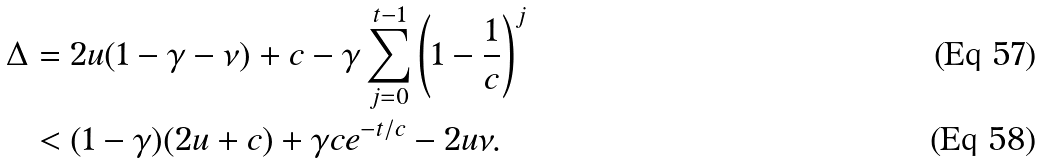Convert formula to latex. <formula><loc_0><loc_0><loc_500><loc_500>\Delta & = 2 u ( 1 - \gamma - \nu ) + c - \gamma \sum _ { j = 0 } ^ { t - 1 } \left ( 1 - \frac { 1 } { c } \right ) ^ { j } \\ & < ( 1 - \gamma ) ( 2 u + c ) + \gamma c e ^ { - t / c } - 2 u \nu .</formula> 